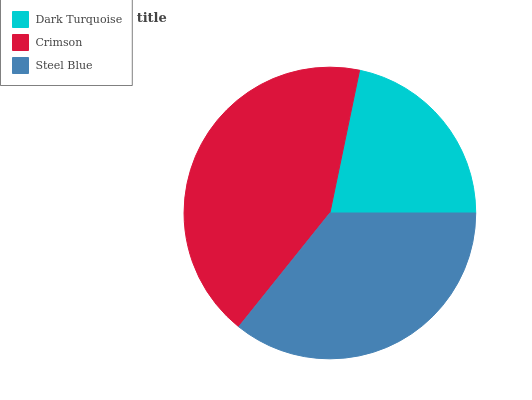Is Dark Turquoise the minimum?
Answer yes or no. Yes. Is Crimson the maximum?
Answer yes or no. Yes. Is Steel Blue the minimum?
Answer yes or no. No. Is Steel Blue the maximum?
Answer yes or no. No. Is Crimson greater than Steel Blue?
Answer yes or no. Yes. Is Steel Blue less than Crimson?
Answer yes or no. Yes. Is Steel Blue greater than Crimson?
Answer yes or no. No. Is Crimson less than Steel Blue?
Answer yes or no. No. Is Steel Blue the high median?
Answer yes or no. Yes. Is Steel Blue the low median?
Answer yes or no. Yes. Is Dark Turquoise the high median?
Answer yes or no. No. Is Crimson the low median?
Answer yes or no. No. 